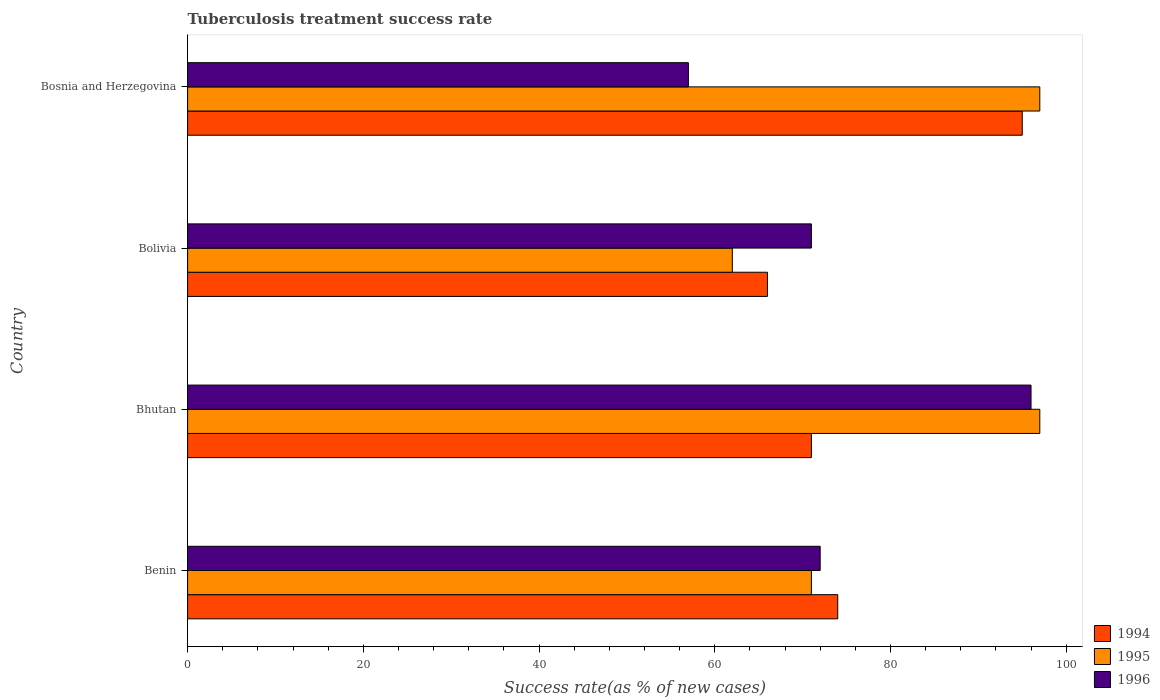How many different coloured bars are there?
Keep it short and to the point. 3. How many groups of bars are there?
Give a very brief answer. 4. How many bars are there on the 1st tick from the top?
Make the answer very short. 3. What is the label of the 3rd group of bars from the top?
Keep it short and to the point. Bhutan. What is the tuberculosis treatment success rate in 1996 in Benin?
Ensure brevity in your answer.  72. Across all countries, what is the maximum tuberculosis treatment success rate in 1995?
Your response must be concise. 97. Across all countries, what is the minimum tuberculosis treatment success rate in 1995?
Provide a succinct answer. 62. In which country was the tuberculosis treatment success rate in 1996 maximum?
Offer a very short reply. Bhutan. In which country was the tuberculosis treatment success rate in 1996 minimum?
Your answer should be very brief. Bosnia and Herzegovina. What is the total tuberculosis treatment success rate in 1996 in the graph?
Provide a short and direct response. 296. What is the difference between the tuberculosis treatment success rate in 1995 in Bolivia and that in Bosnia and Herzegovina?
Offer a terse response. -35. What is the difference between the tuberculosis treatment success rate in 1996 in Bhutan and the tuberculosis treatment success rate in 1995 in Bosnia and Herzegovina?
Provide a short and direct response. -1. What is the difference between the tuberculosis treatment success rate in 1995 and tuberculosis treatment success rate in 1996 in Bolivia?
Offer a terse response. -9. What is the ratio of the tuberculosis treatment success rate in 1995 in Bhutan to that in Bolivia?
Your answer should be very brief. 1.56. What is the difference between the highest and the lowest tuberculosis treatment success rate in 1996?
Make the answer very short. 39. Is the sum of the tuberculosis treatment success rate in 1994 in Benin and Bolivia greater than the maximum tuberculosis treatment success rate in 1996 across all countries?
Your answer should be compact. Yes. What does the 2nd bar from the top in Benin represents?
Your answer should be compact. 1995. What does the 2nd bar from the bottom in Bosnia and Herzegovina represents?
Provide a short and direct response. 1995. Is it the case that in every country, the sum of the tuberculosis treatment success rate in 1994 and tuberculosis treatment success rate in 1996 is greater than the tuberculosis treatment success rate in 1995?
Make the answer very short. Yes. Are all the bars in the graph horizontal?
Ensure brevity in your answer.  Yes. How many countries are there in the graph?
Keep it short and to the point. 4. Are the values on the major ticks of X-axis written in scientific E-notation?
Your answer should be compact. No. How are the legend labels stacked?
Offer a very short reply. Vertical. What is the title of the graph?
Offer a terse response. Tuberculosis treatment success rate. What is the label or title of the X-axis?
Your answer should be very brief. Success rate(as % of new cases). What is the label or title of the Y-axis?
Make the answer very short. Country. What is the Success rate(as % of new cases) of 1995 in Benin?
Keep it short and to the point. 71. What is the Success rate(as % of new cases) of 1996 in Benin?
Provide a short and direct response. 72. What is the Success rate(as % of new cases) of 1995 in Bhutan?
Offer a terse response. 97. What is the Success rate(as % of new cases) in 1996 in Bhutan?
Provide a succinct answer. 96. What is the Success rate(as % of new cases) of 1994 in Bolivia?
Your answer should be very brief. 66. What is the Success rate(as % of new cases) in 1996 in Bolivia?
Give a very brief answer. 71. What is the Success rate(as % of new cases) of 1995 in Bosnia and Herzegovina?
Provide a succinct answer. 97. What is the Success rate(as % of new cases) in 1996 in Bosnia and Herzegovina?
Ensure brevity in your answer.  57. Across all countries, what is the maximum Success rate(as % of new cases) in 1995?
Ensure brevity in your answer.  97. Across all countries, what is the maximum Success rate(as % of new cases) in 1996?
Make the answer very short. 96. Across all countries, what is the minimum Success rate(as % of new cases) in 1994?
Your response must be concise. 66. Across all countries, what is the minimum Success rate(as % of new cases) in 1995?
Ensure brevity in your answer.  62. What is the total Success rate(as % of new cases) of 1994 in the graph?
Give a very brief answer. 306. What is the total Success rate(as % of new cases) of 1995 in the graph?
Offer a terse response. 327. What is the total Success rate(as % of new cases) of 1996 in the graph?
Your answer should be very brief. 296. What is the difference between the Success rate(as % of new cases) of 1995 in Benin and that in Bhutan?
Offer a terse response. -26. What is the difference between the Success rate(as % of new cases) of 1996 in Benin and that in Bhutan?
Provide a short and direct response. -24. What is the difference between the Success rate(as % of new cases) of 1995 in Benin and that in Bolivia?
Your answer should be compact. 9. What is the difference between the Success rate(as % of new cases) in 1996 in Benin and that in Bosnia and Herzegovina?
Provide a short and direct response. 15. What is the difference between the Success rate(as % of new cases) of 1994 in Bhutan and that in Bolivia?
Your answer should be very brief. 5. What is the difference between the Success rate(as % of new cases) in 1996 in Bhutan and that in Bolivia?
Offer a terse response. 25. What is the difference between the Success rate(as % of new cases) of 1995 in Bhutan and that in Bosnia and Herzegovina?
Ensure brevity in your answer.  0. What is the difference between the Success rate(as % of new cases) of 1996 in Bhutan and that in Bosnia and Herzegovina?
Provide a succinct answer. 39. What is the difference between the Success rate(as % of new cases) of 1995 in Bolivia and that in Bosnia and Herzegovina?
Keep it short and to the point. -35. What is the difference between the Success rate(as % of new cases) of 1996 in Bolivia and that in Bosnia and Herzegovina?
Provide a succinct answer. 14. What is the difference between the Success rate(as % of new cases) of 1994 in Benin and the Success rate(as % of new cases) of 1996 in Bhutan?
Offer a very short reply. -22. What is the difference between the Success rate(as % of new cases) in 1995 in Benin and the Success rate(as % of new cases) in 1996 in Bhutan?
Provide a short and direct response. -25. What is the difference between the Success rate(as % of new cases) of 1994 in Benin and the Success rate(as % of new cases) of 1995 in Bolivia?
Your answer should be very brief. 12. What is the difference between the Success rate(as % of new cases) in 1994 in Benin and the Success rate(as % of new cases) in 1996 in Bolivia?
Ensure brevity in your answer.  3. What is the difference between the Success rate(as % of new cases) in 1995 in Benin and the Success rate(as % of new cases) in 1996 in Bolivia?
Make the answer very short. 0. What is the difference between the Success rate(as % of new cases) of 1994 in Benin and the Success rate(as % of new cases) of 1995 in Bosnia and Herzegovina?
Provide a succinct answer. -23. What is the difference between the Success rate(as % of new cases) of 1994 in Benin and the Success rate(as % of new cases) of 1996 in Bosnia and Herzegovina?
Give a very brief answer. 17. What is the difference between the Success rate(as % of new cases) in 1995 in Bhutan and the Success rate(as % of new cases) in 1996 in Bosnia and Herzegovina?
Ensure brevity in your answer.  40. What is the difference between the Success rate(as % of new cases) in 1994 in Bolivia and the Success rate(as % of new cases) in 1995 in Bosnia and Herzegovina?
Your response must be concise. -31. What is the difference between the Success rate(as % of new cases) of 1994 in Bolivia and the Success rate(as % of new cases) of 1996 in Bosnia and Herzegovina?
Provide a short and direct response. 9. What is the difference between the Success rate(as % of new cases) of 1995 in Bolivia and the Success rate(as % of new cases) of 1996 in Bosnia and Herzegovina?
Your response must be concise. 5. What is the average Success rate(as % of new cases) in 1994 per country?
Your answer should be compact. 76.5. What is the average Success rate(as % of new cases) of 1995 per country?
Give a very brief answer. 81.75. What is the difference between the Success rate(as % of new cases) in 1994 and Success rate(as % of new cases) in 1995 in Benin?
Your answer should be compact. 3. What is the difference between the Success rate(as % of new cases) of 1994 and Success rate(as % of new cases) of 1996 in Benin?
Your response must be concise. 2. What is the difference between the Success rate(as % of new cases) in 1995 and Success rate(as % of new cases) in 1996 in Benin?
Your answer should be compact. -1. What is the difference between the Success rate(as % of new cases) of 1994 and Success rate(as % of new cases) of 1996 in Bhutan?
Keep it short and to the point. -25. What is the difference between the Success rate(as % of new cases) of 1994 and Success rate(as % of new cases) of 1996 in Bolivia?
Your answer should be very brief. -5. What is the difference between the Success rate(as % of new cases) of 1995 and Success rate(as % of new cases) of 1996 in Bosnia and Herzegovina?
Keep it short and to the point. 40. What is the ratio of the Success rate(as % of new cases) in 1994 in Benin to that in Bhutan?
Keep it short and to the point. 1.04. What is the ratio of the Success rate(as % of new cases) of 1995 in Benin to that in Bhutan?
Give a very brief answer. 0.73. What is the ratio of the Success rate(as % of new cases) in 1996 in Benin to that in Bhutan?
Give a very brief answer. 0.75. What is the ratio of the Success rate(as % of new cases) of 1994 in Benin to that in Bolivia?
Provide a short and direct response. 1.12. What is the ratio of the Success rate(as % of new cases) of 1995 in Benin to that in Bolivia?
Your answer should be very brief. 1.15. What is the ratio of the Success rate(as % of new cases) of 1996 in Benin to that in Bolivia?
Keep it short and to the point. 1.01. What is the ratio of the Success rate(as % of new cases) in 1994 in Benin to that in Bosnia and Herzegovina?
Keep it short and to the point. 0.78. What is the ratio of the Success rate(as % of new cases) of 1995 in Benin to that in Bosnia and Herzegovina?
Give a very brief answer. 0.73. What is the ratio of the Success rate(as % of new cases) in 1996 in Benin to that in Bosnia and Herzegovina?
Offer a very short reply. 1.26. What is the ratio of the Success rate(as % of new cases) of 1994 in Bhutan to that in Bolivia?
Your answer should be very brief. 1.08. What is the ratio of the Success rate(as % of new cases) of 1995 in Bhutan to that in Bolivia?
Your answer should be compact. 1.56. What is the ratio of the Success rate(as % of new cases) in 1996 in Bhutan to that in Bolivia?
Your answer should be very brief. 1.35. What is the ratio of the Success rate(as % of new cases) of 1994 in Bhutan to that in Bosnia and Herzegovina?
Give a very brief answer. 0.75. What is the ratio of the Success rate(as % of new cases) in 1996 in Bhutan to that in Bosnia and Herzegovina?
Make the answer very short. 1.68. What is the ratio of the Success rate(as % of new cases) of 1994 in Bolivia to that in Bosnia and Herzegovina?
Your response must be concise. 0.69. What is the ratio of the Success rate(as % of new cases) of 1995 in Bolivia to that in Bosnia and Herzegovina?
Your answer should be very brief. 0.64. What is the ratio of the Success rate(as % of new cases) in 1996 in Bolivia to that in Bosnia and Herzegovina?
Give a very brief answer. 1.25. What is the difference between the highest and the second highest Success rate(as % of new cases) of 1994?
Keep it short and to the point. 21. What is the difference between the highest and the second highest Success rate(as % of new cases) of 1995?
Your response must be concise. 0. What is the difference between the highest and the second highest Success rate(as % of new cases) in 1996?
Give a very brief answer. 24. What is the difference between the highest and the lowest Success rate(as % of new cases) in 1994?
Provide a short and direct response. 29. What is the difference between the highest and the lowest Success rate(as % of new cases) of 1995?
Offer a terse response. 35. What is the difference between the highest and the lowest Success rate(as % of new cases) in 1996?
Give a very brief answer. 39. 